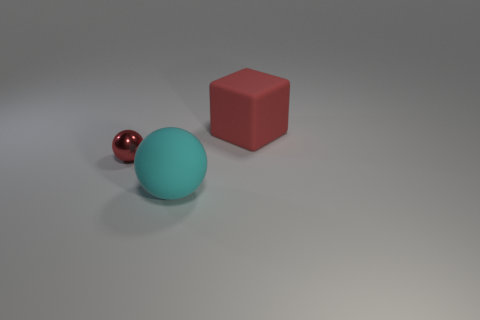Is there anything else that is the same material as the red ball?
Your answer should be very brief. No. What number of other objects are there of the same color as the block?
Your answer should be very brief. 1. There is a sphere to the left of the rubber sphere; is its size the same as the big red rubber block?
Provide a succinct answer. No. Are there any red things of the same size as the block?
Provide a short and direct response. No. What color is the matte object that is in front of the tiny red metal object?
Give a very brief answer. Cyan. The thing that is in front of the red rubber block and behind the large cyan rubber ball has what shape?
Your answer should be very brief. Sphere. What number of other shiny objects are the same shape as the large cyan object?
Your response must be concise. 1. How many red rubber objects are there?
Keep it short and to the point. 1. There is a object that is both behind the cyan matte ball and in front of the red rubber thing; what size is it?
Your answer should be very brief. Small. What shape is the red matte object that is the same size as the cyan ball?
Your answer should be very brief. Cube. 